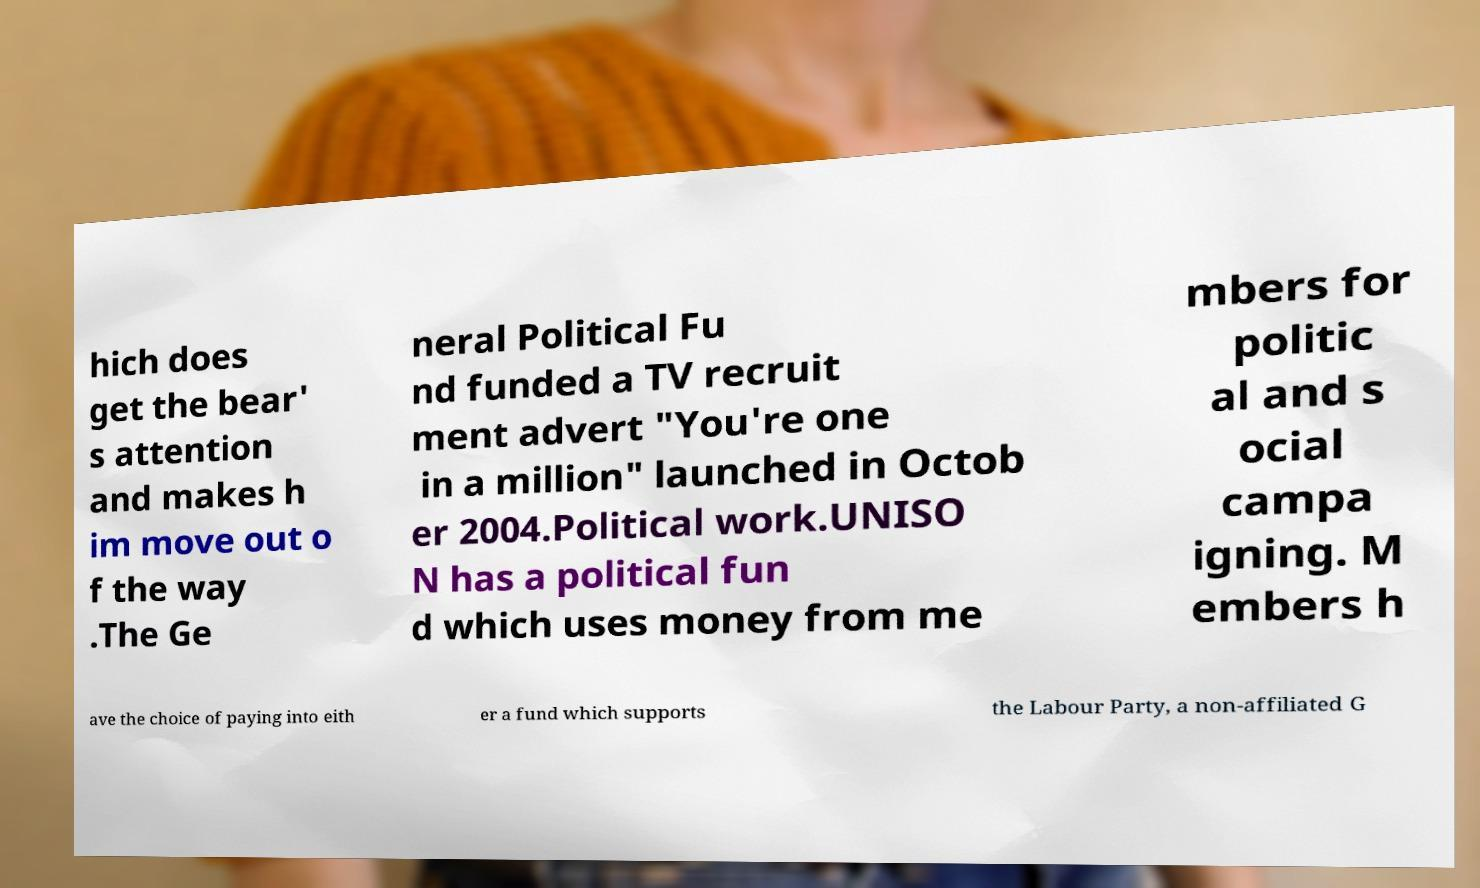What messages or text are displayed in this image? I need them in a readable, typed format. hich does get the bear' s attention and makes h im move out o f the way .The Ge neral Political Fu nd funded a TV recruit ment advert "You're one in a million" launched in Octob er 2004.Political work.UNISO N has a political fun d which uses money from me mbers for politic al and s ocial campa igning. M embers h ave the choice of paying into eith er a fund which supports the Labour Party, a non-affiliated G 